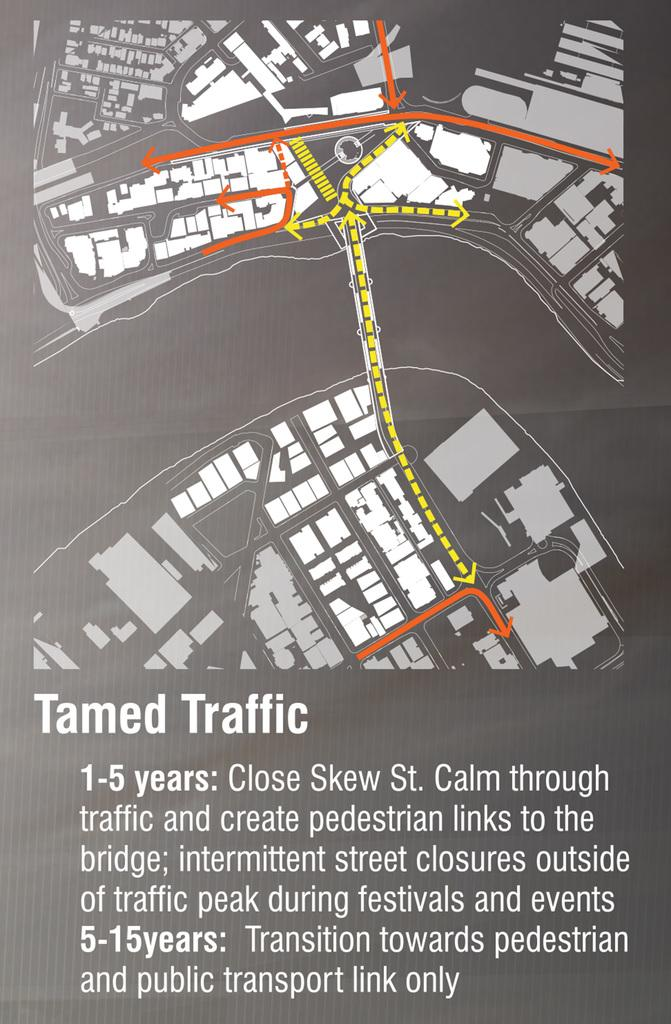Provide a one-sentence caption for the provided image. Map or sketch showing "tamed traffic" in grey and white. 